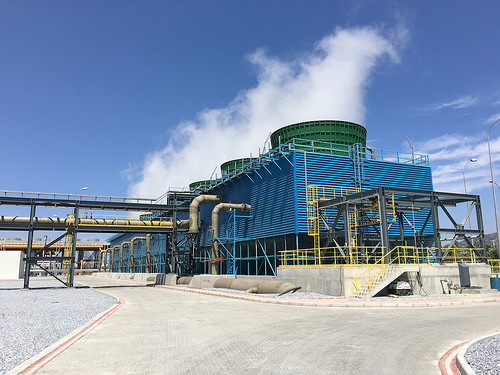<image>
Can you confirm if the sky is behind the factory? Yes. From this viewpoint, the sky is positioned behind the factory, with the factory partially or fully occluding the sky. 